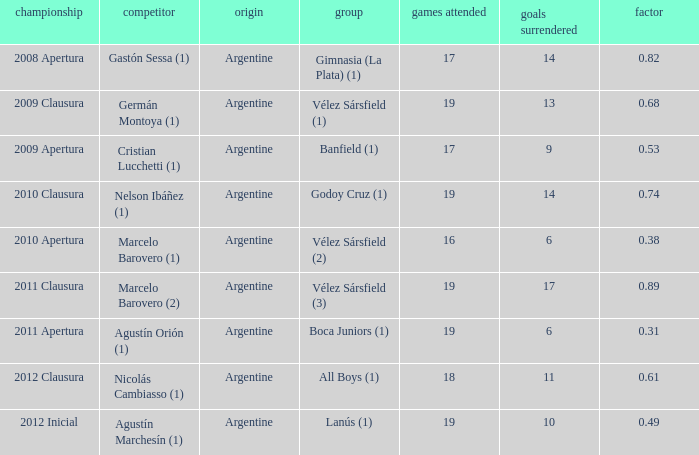 the 2010 clausura tournament? 0.74. 